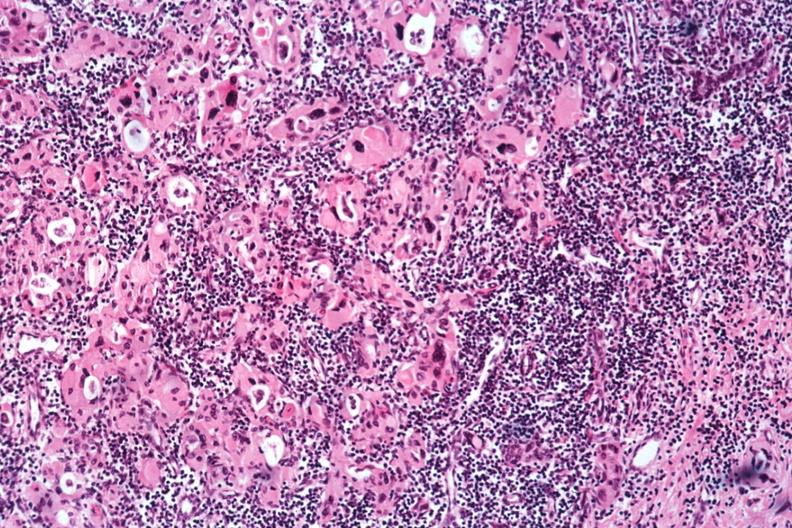does this image show med bizarre hurthle type cells with lymphocytic infiltrate no recognizable thyroid tissue?
Answer the question using a single word or phrase. Yes 